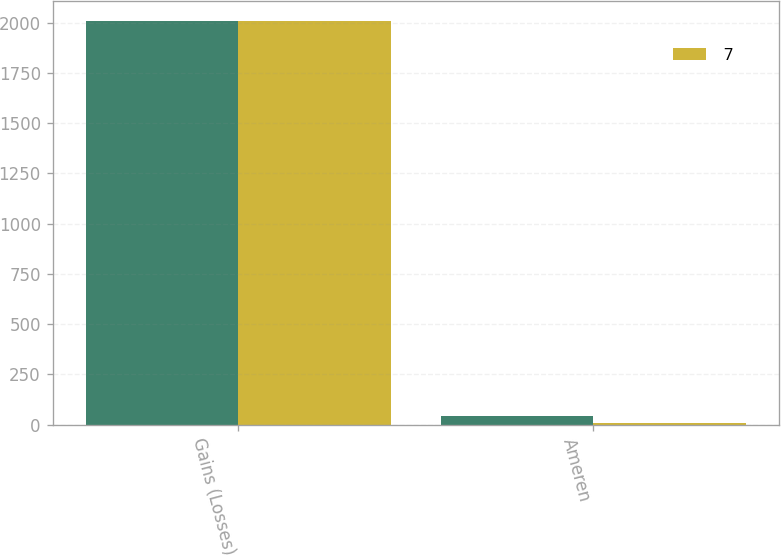<chart> <loc_0><loc_0><loc_500><loc_500><stacked_bar_chart><ecel><fcel>Gains (Losses)<fcel>Ameren<nl><fcel>nan<fcel>2007<fcel>40<nl><fcel>7<fcel>2006<fcel>9<nl></chart> 